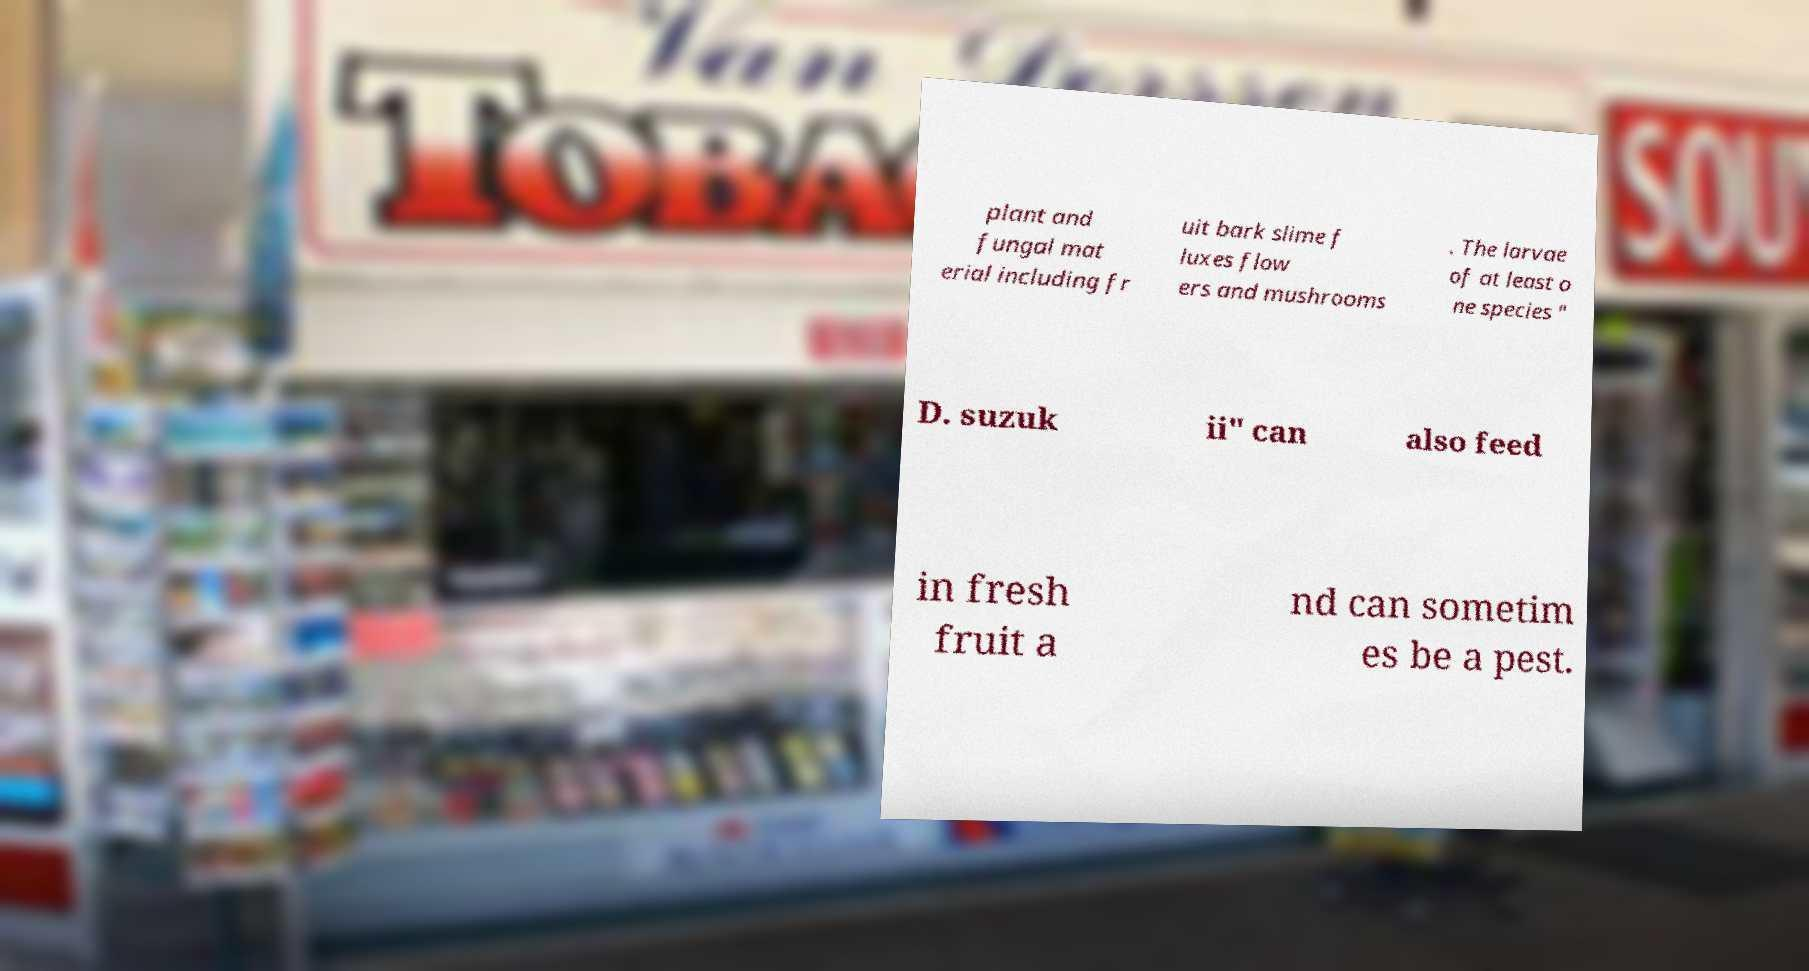I need the written content from this picture converted into text. Can you do that? plant and fungal mat erial including fr uit bark slime f luxes flow ers and mushrooms . The larvae of at least o ne species " D. suzuk ii" can also feed in fresh fruit a nd can sometim es be a pest. 